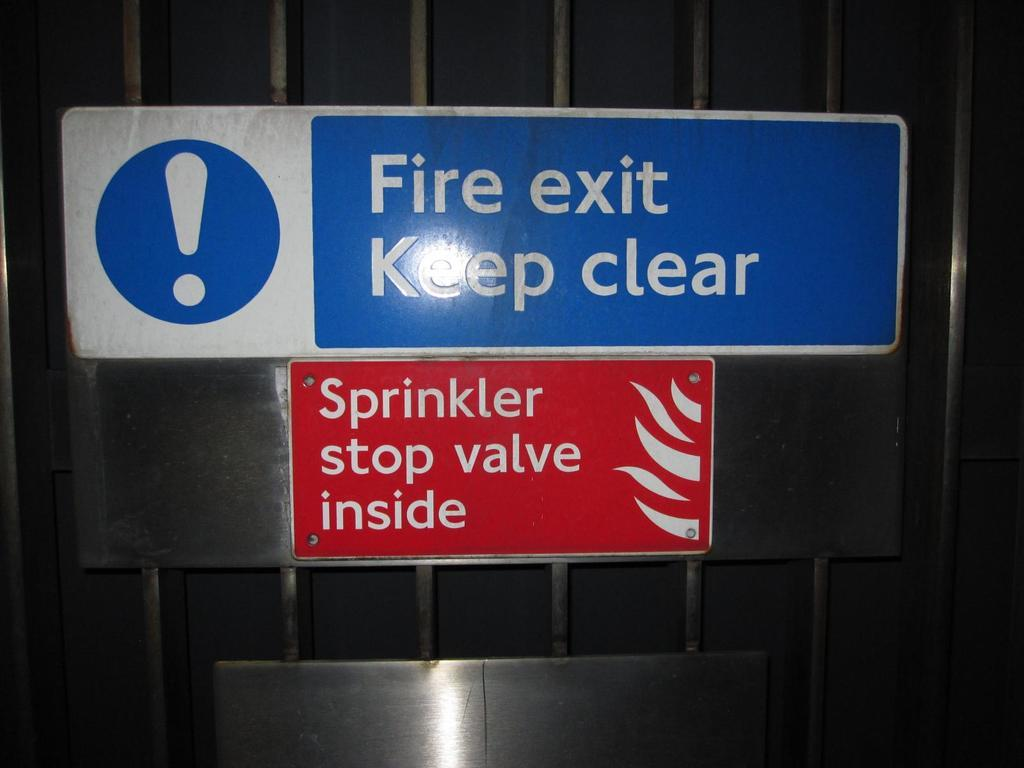Provide a one-sentence caption for the provided image. The Fire exit must be kept clear claims the blue and white sign with a big exclamation mark on it. 